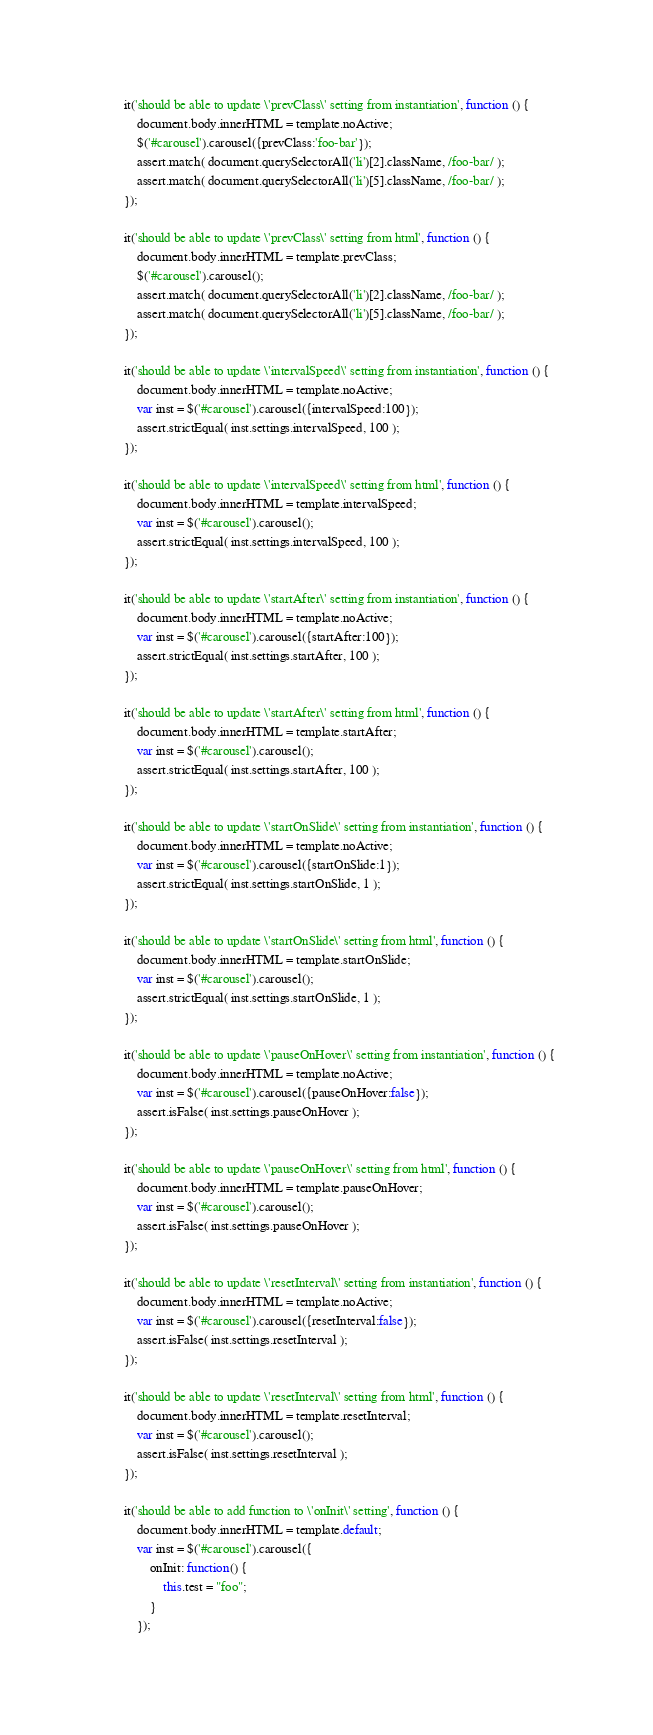Convert code to text. <code><loc_0><loc_0><loc_500><loc_500><_JavaScript_>
        it('should be able to update \'prevClass\' setting from instantiation', function () {
            document.body.innerHTML = template.noActive;
            $('#carousel').carousel({prevClass:'foo-bar'});
            assert.match( document.querySelectorAll('li')[2].className, /foo-bar/ );
            assert.match( document.querySelectorAll('li')[5].className, /foo-bar/ );
        });

        it('should be able to update \'prevClass\' setting from html', function () {
            document.body.innerHTML = template.prevClass;
            $('#carousel').carousel();
            assert.match( document.querySelectorAll('li')[2].className, /foo-bar/ );
            assert.match( document.querySelectorAll('li')[5].className, /foo-bar/ );
        });

        it('should be able to update \'intervalSpeed\' setting from instantiation', function () {
            document.body.innerHTML = template.noActive;
            var inst = $('#carousel').carousel({intervalSpeed:100});
            assert.strictEqual( inst.settings.intervalSpeed, 100 );
        });

        it('should be able to update \'intervalSpeed\' setting from html', function () {
            document.body.innerHTML = template.intervalSpeed;
            var inst = $('#carousel').carousel();
            assert.strictEqual( inst.settings.intervalSpeed, 100 );
        });

        it('should be able to update \'startAfter\' setting from instantiation', function () {
            document.body.innerHTML = template.noActive;
            var inst = $('#carousel').carousel({startAfter:100});
            assert.strictEqual( inst.settings.startAfter, 100 );
        });

        it('should be able to update \'startAfter\' setting from html', function () {
            document.body.innerHTML = template.startAfter;
            var inst = $('#carousel').carousel();
            assert.strictEqual( inst.settings.startAfter, 100 );
        });

        it('should be able to update \'startOnSlide\' setting from instantiation', function () {
            document.body.innerHTML = template.noActive;
            var inst = $('#carousel').carousel({startOnSlide:1});
            assert.strictEqual( inst.settings.startOnSlide, 1 );
        });

        it('should be able to update \'startOnSlide\' setting from html', function () {
            document.body.innerHTML = template.startOnSlide;
            var inst = $('#carousel').carousel();
            assert.strictEqual( inst.settings.startOnSlide, 1 );
        });

        it('should be able to update \'pauseOnHover\' setting from instantiation', function () {
            document.body.innerHTML = template.noActive;
            var inst = $('#carousel').carousel({pauseOnHover:false});
            assert.isFalse( inst.settings.pauseOnHover );
        });

        it('should be able to update \'pauseOnHover\' setting from html', function () {
            document.body.innerHTML = template.pauseOnHover;
            var inst = $('#carousel').carousel();
            assert.isFalse( inst.settings.pauseOnHover );
        });

        it('should be able to update \'resetInterval\' setting from instantiation', function () {
            document.body.innerHTML = template.noActive;
            var inst = $('#carousel').carousel({resetInterval:false});
            assert.isFalse( inst.settings.resetInterval );
        });

        it('should be able to update \'resetInterval\' setting from html', function () {
            document.body.innerHTML = template.resetInterval;
            var inst = $('#carousel').carousel();
            assert.isFalse( inst.settings.resetInterval );
        });

        it('should be able to add function to \'onInit\' setting', function () {
            document.body.innerHTML = template.default;
            var inst = $('#carousel').carousel({
                onInit: function() {
                    this.test = "foo";
                }
            });</code> 